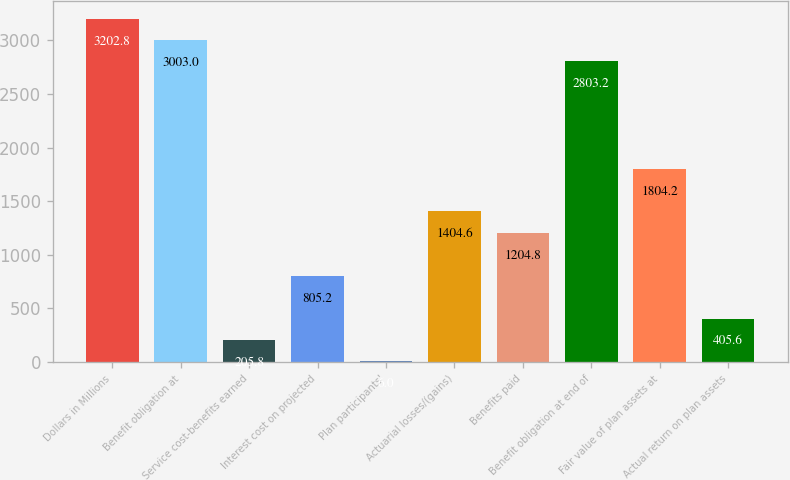<chart> <loc_0><loc_0><loc_500><loc_500><bar_chart><fcel>Dollars in Millions<fcel>Benefit obligation at<fcel>Service cost-benefits earned<fcel>Interest cost on projected<fcel>Plan participants'<fcel>Actuarial losses/(gains)<fcel>Benefits paid<fcel>Benefit obligation at end of<fcel>Fair value of plan assets at<fcel>Actual return on plan assets<nl><fcel>3202.8<fcel>3003<fcel>205.8<fcel>805.2<fcel>6<fcel>1404.6<fcel>1204.8<fcel>2803.2<fcel>1804.2<fcel>405.6<nl></chart> 